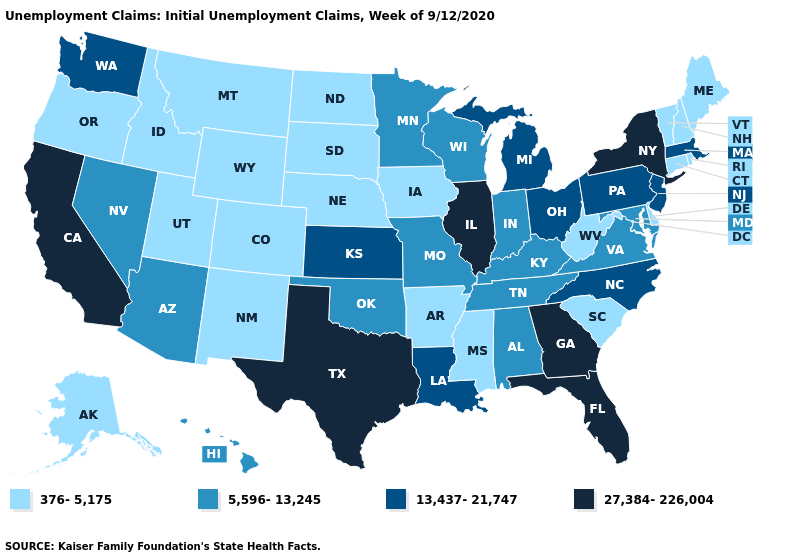Name the states that have a value in the range 5,596-13,245?
Answer briefly. Alabama, Arizona, Hawaii, Indiana, Kentucky, Maryland, Minnesota, Missouri, Nevada, Oklahoma, Tennessee, Virginia, Wisconsin. What is the value of New Hampshire?
Be succinct. 376-5,175. What is the value of Delaware?
Write a very short answer. 376-5,175. What is the value of Colorado?
Give a very brief answer. 376-5,175. What is the highest value in the USA?
Give a very brief answer. 27,384-226,004. Name the states that have a value in the range 376-5,175?
Answer briefly. Alaska, Arkansas, Colorado, Connecticut, Delaware, Idaho, Iowa, Maine, Mississippi, Montana, Nebraska, New Hampshire, New Mexico, North Dakota, Oregon, Rhode Island, South Carolina, South Dakota, Utah, Vermont, West Virginia, Wyoming. What is the lowest value in states that border Wisconsin?
Short answer required. 376-5,175. What is the lowest value in states that border Massachusetts?
Quick response, please. 376-5,175. What is the value of Wyoming?
Give a very brief answer. 376-5,175. Does Massachusetts have a lower value than Maryland?
Keep it brief. No. What is the value of Missouri?
Give a very brief answer. 5,596-13,245. Name the states that have a value in the range 27,384-226,004?
Concise answer only. California, Florida, Georgia, Illinois, New York, Texas. Which states have the highest value in the USA?
Quick response, please. California, Florida, Georgia, Illinois, New York, Texas. Name the states that have a value in the range 5,596-13,245?
Concise answer only. Alabama, Arizona, Hawaii, Indiana, Kentucky, Maryland, Minnesota, Missouri, Nevada, Oklahoma, Tennessee, Virginia, Wisconsin. Which states have the highest value in the USA?
Quick response, please. California, Florida, Georgia, Illinois, New York, Texas. 